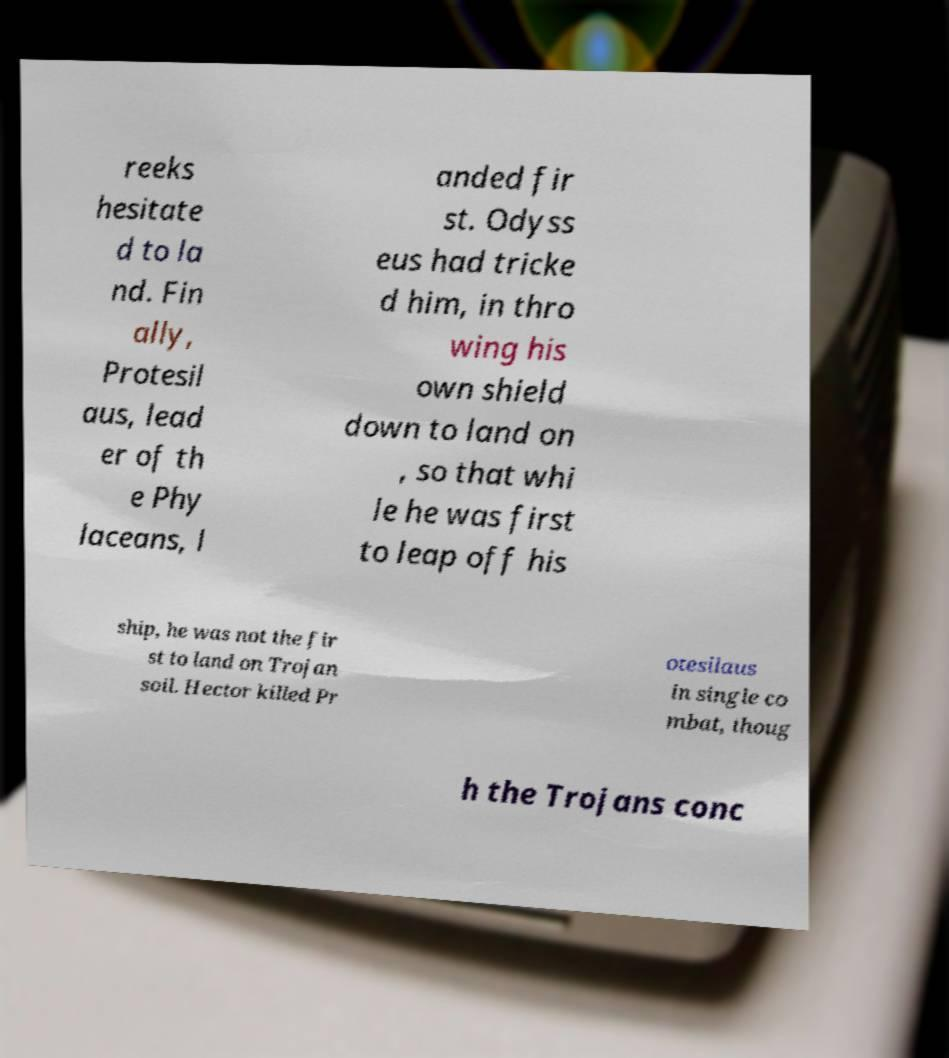Could you extract and type out the text from this image? reeks hesitate d to la nd. Fin ally, Protesil aus, lead er of th e Phy laceans, l anded fir st. Odyss eus had tricke d him, in thro wing his own shield down to land on , so that whi le he was first to leap off his ship, he was not the fir st to land on Trojan soil. Hector killed Pr otesilaus in single co mbat, thoug h the Trojans conc 